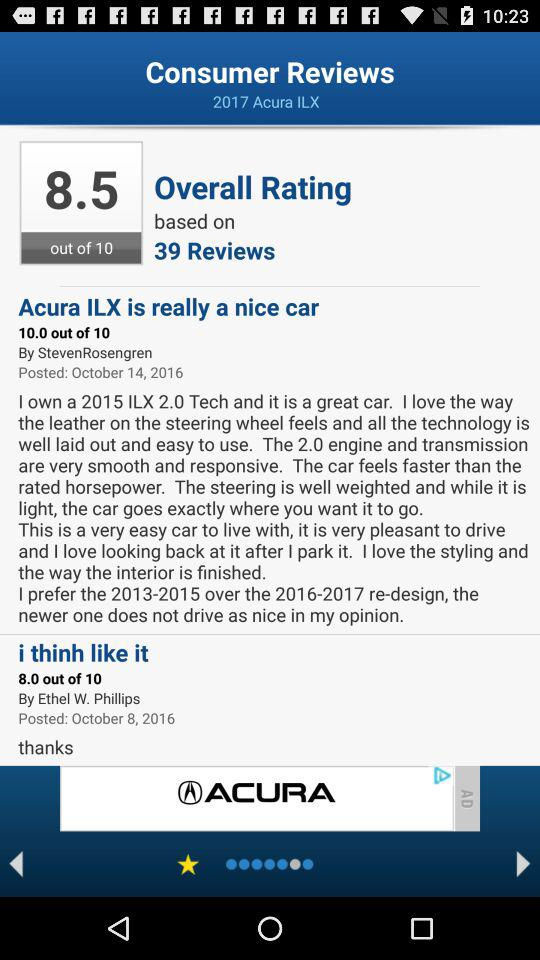What's the posted date of the review "Acura ILX is really a nice car"? The posted date is October 14, 2016. 